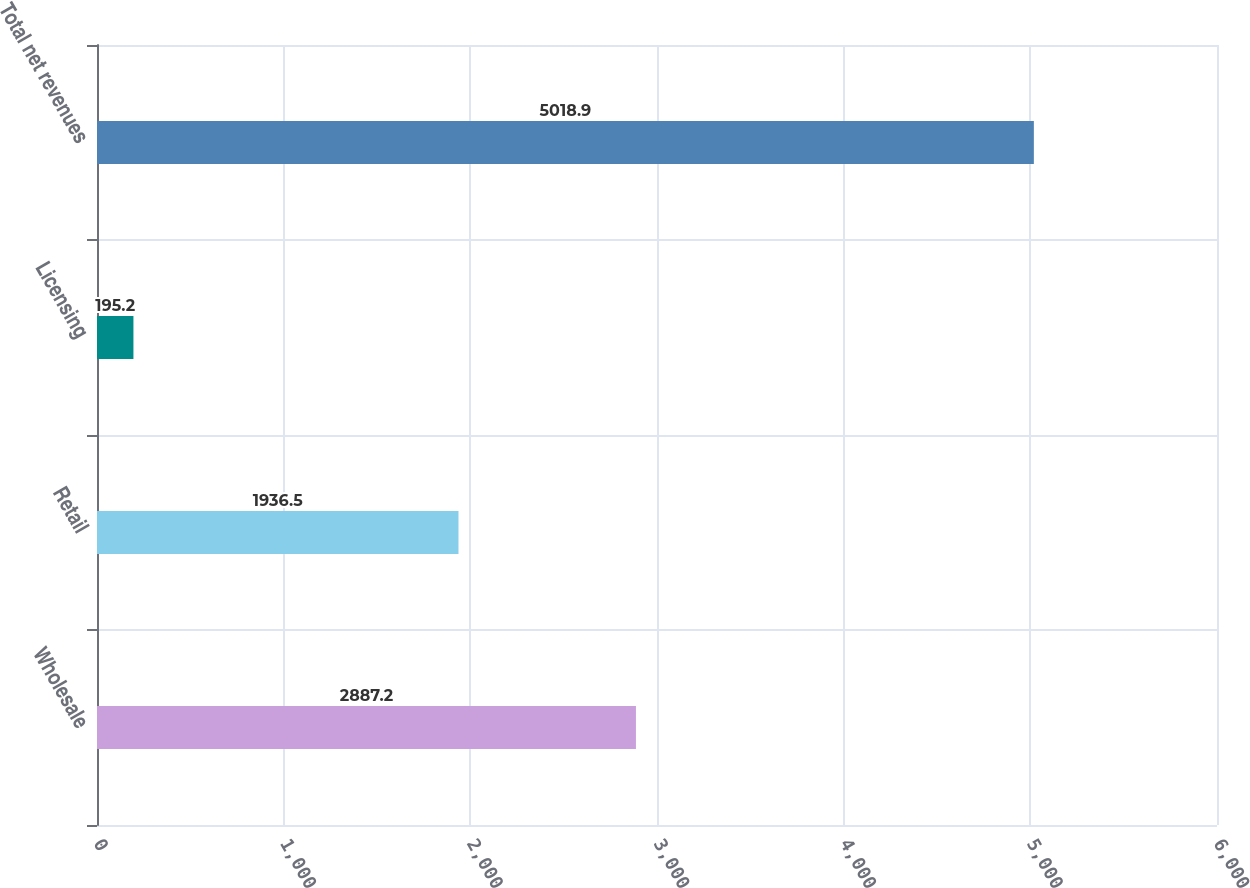Convert chart to OTSL. <chart><loc_0><loc_0><loc_500><loc_500><bar_chart><fcel>Wholesale<fcel>Retail<fcel>Licensing<fcel>Total net revenues<nl><fcel>2887.2<fcel>1936.5<fcel>195.2<fcel>5018.9<nl></chart> 